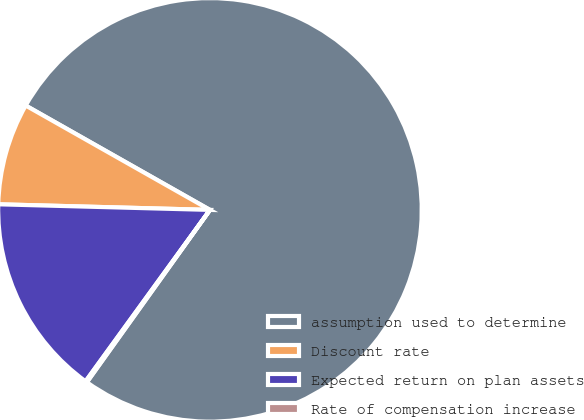<chart> <loc_0><loc_0><loc_500><loc_500><pie_chart><fcel>assumption used to determine<fcel>Discount rate<fcel>Expected return on plan assets<fcel>Rate of compensation increase<nl><fcel>76.67%<fcel>7.78%<fcel>15.43%<fcel>0.12%<nl></chart> 